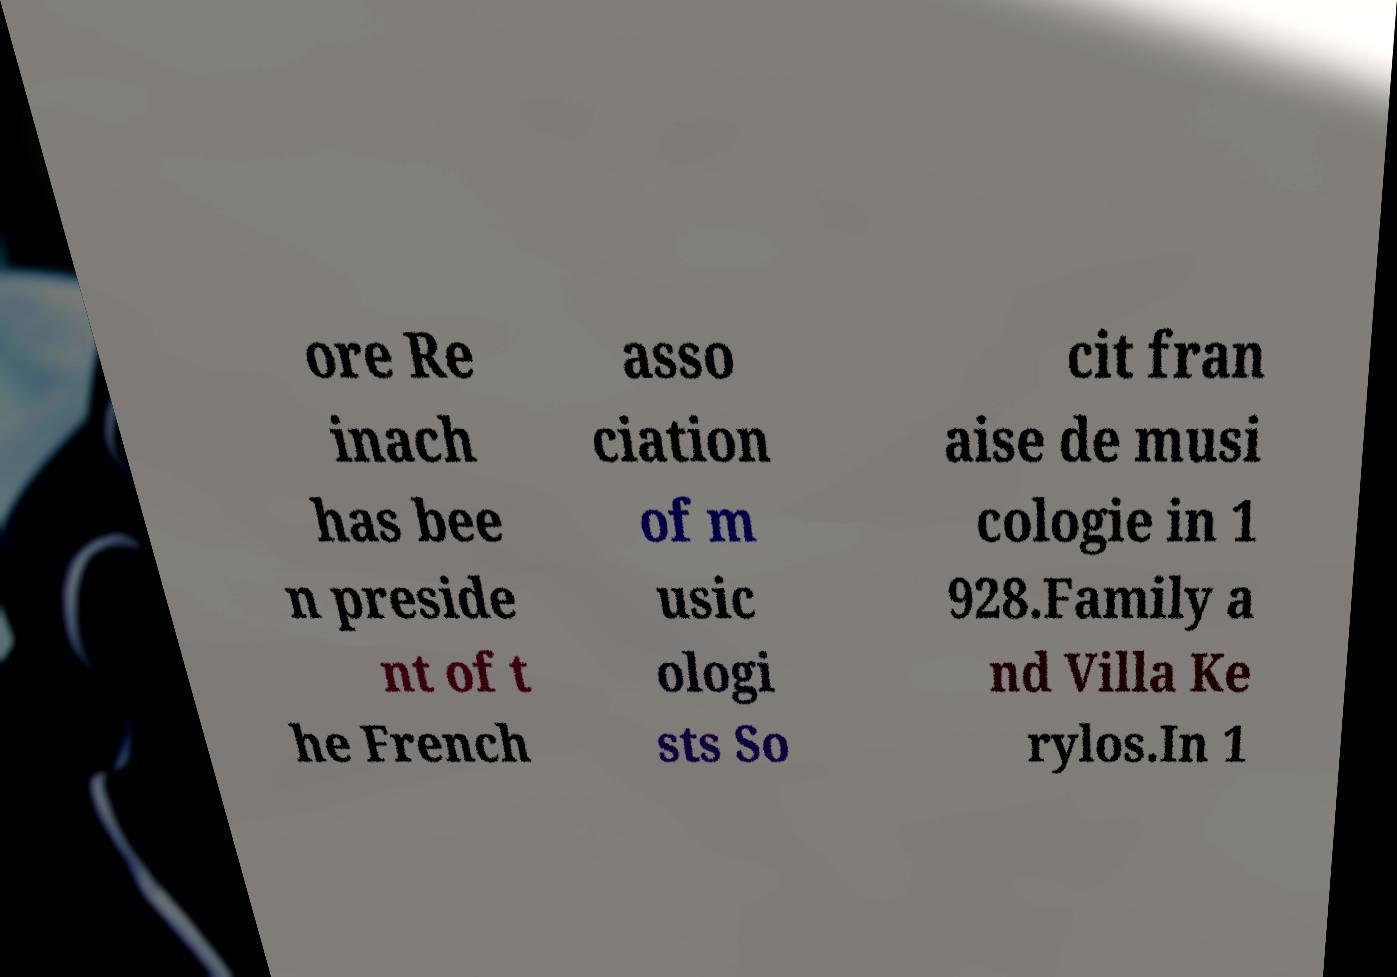Can you read and provide the text displayed in the image?This photo seems to have some interesting text. Can you extract and type it out for me? ore Re inach has bee n preside nt of t he French asso ciation of m usic ologi sts So cit fran aise de musi cologie in 1 928.Family a nd Villa Ke rylos.In 1 